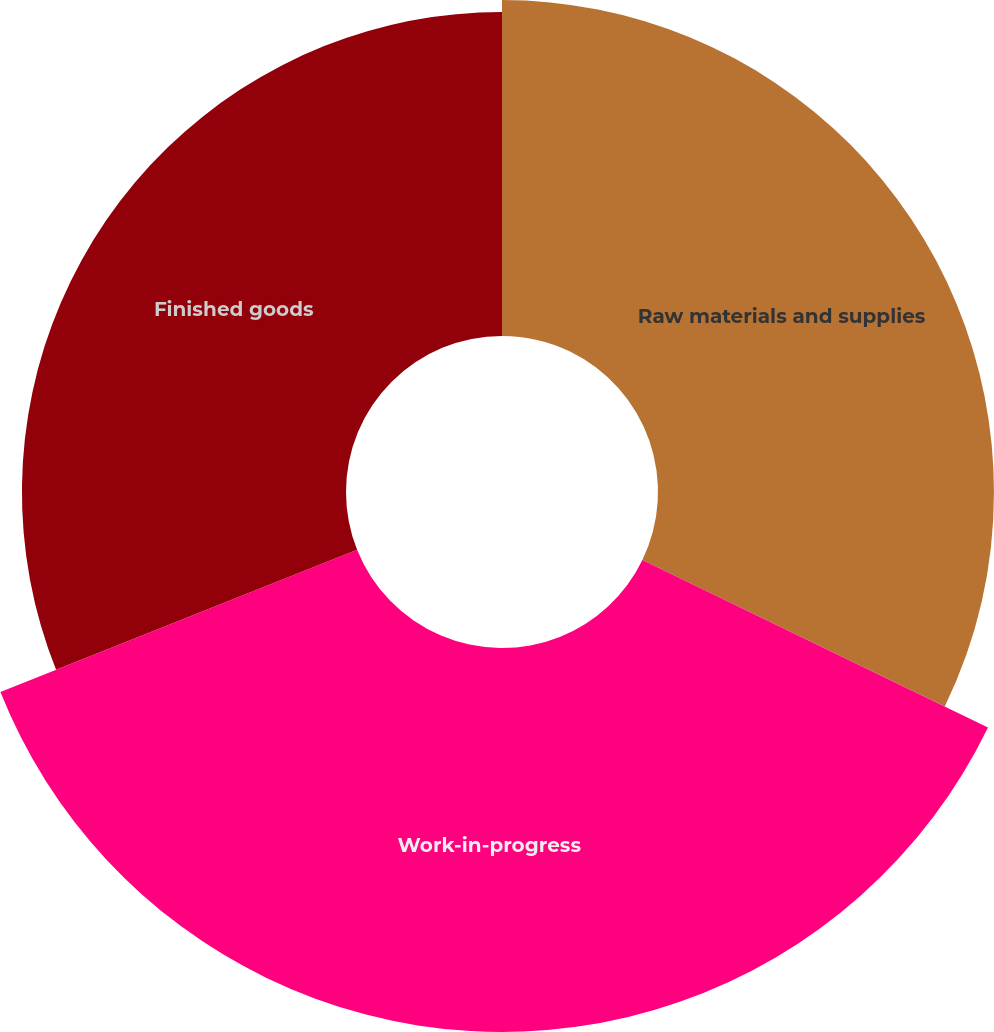<chart> <loc_0><loc_0><loc_500><loc_500><pie_chart><fcel>Raw materials and supplies<fcel>Work-in-progress<fcel>Finished goods<nl><fcel>32.18%<fcel>36.78%<fcel>31.04%<nl></chart> 